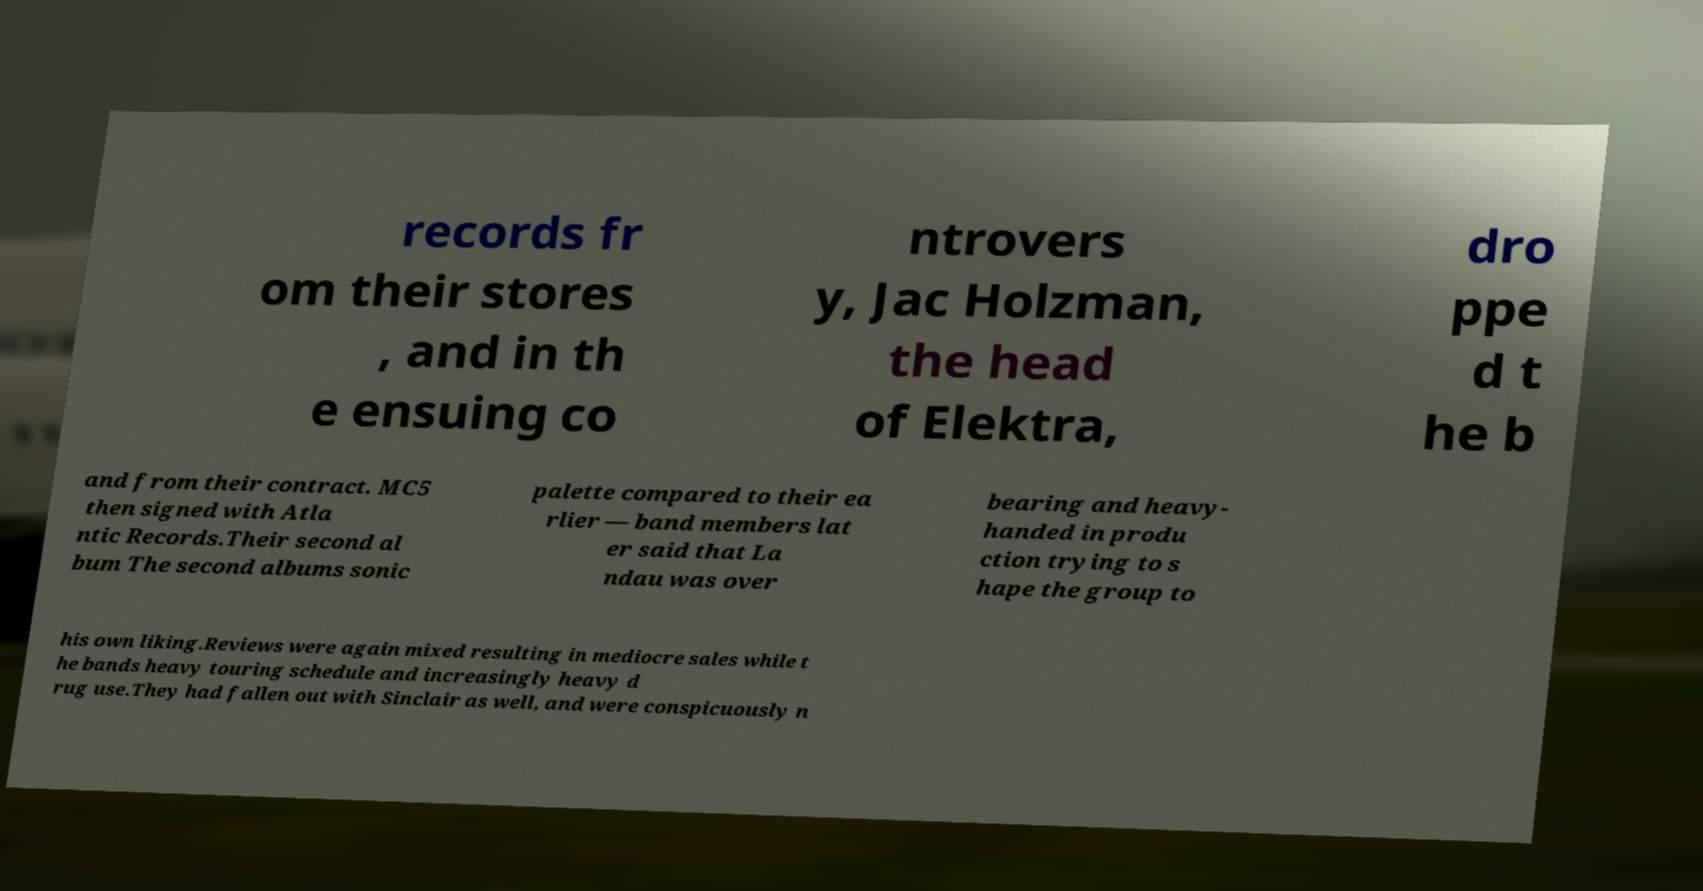Could you extract and type out the text from this image? records fr om their stores , and in th e ensuing co ntrovers y, Jac Holzman, the head of Elektra, dro ppe d t he b and from their contract. MC5 then signed with Atla ntic Records.Their second al bum The second albums sonic palette compared to their ea rlier — band members lat er said that La ndau was over bearing and heavy- handed in produ ction trying to s hape the group to his own liking.Reviews were again mixed resulting in mediocre sales while t he bands heavy touring schedule and increasingly heavy d rug use.They had fallen out with Sinclair as well, and were conspicuously n 